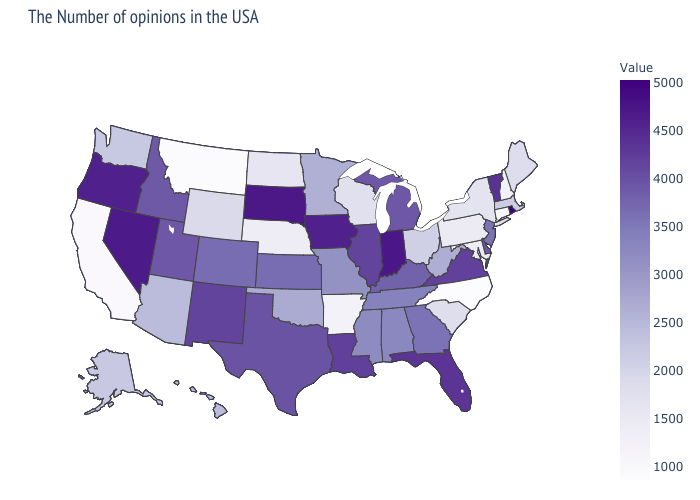Among the states that border Louisiana , which have the lowest value?
Be succinct. Arkansas. Which states have the lowest value in the Northeast?
Give a very brief answer. Connecticut. Which states have the lowest value in the MidWest?
Give a very brief answer. Nebraska. Does North Dakota have a higher value than Georgia?
Answer briefly. No. 